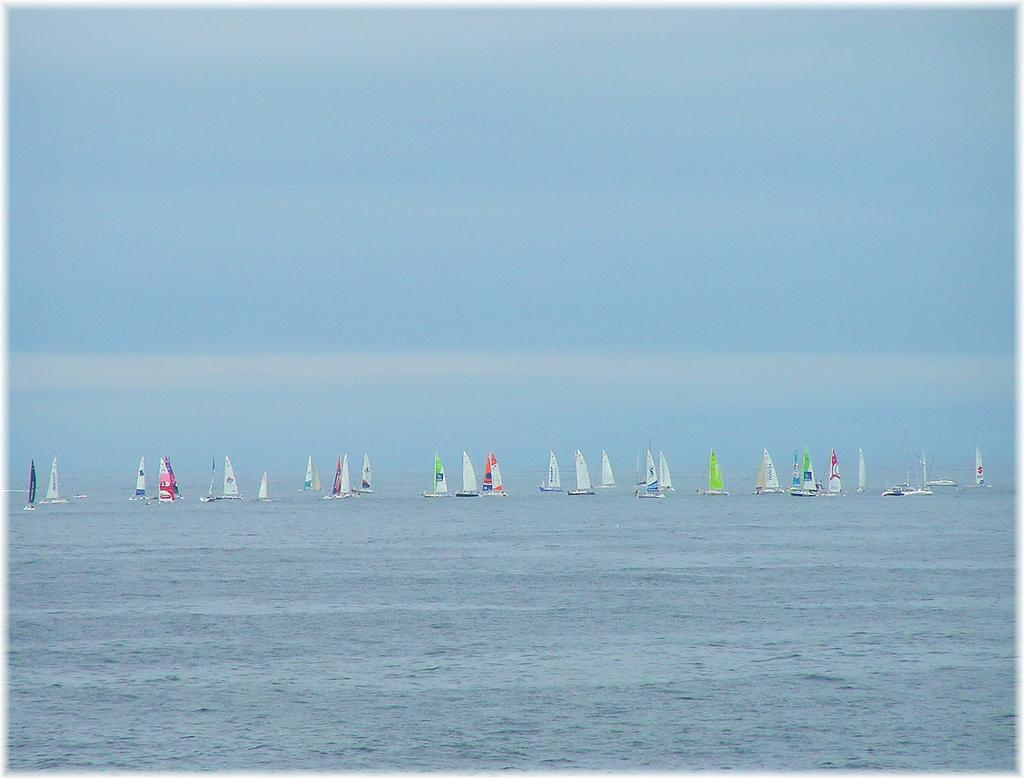What is the main subject of the image? The main subject of the image is many ships. Where are the ships located? The ships are sailing on the sea. What feature is present on each ship? Each ship has its own mast. What type of hat is the grass wearing in the image? There is no grass or hat present in the image. 